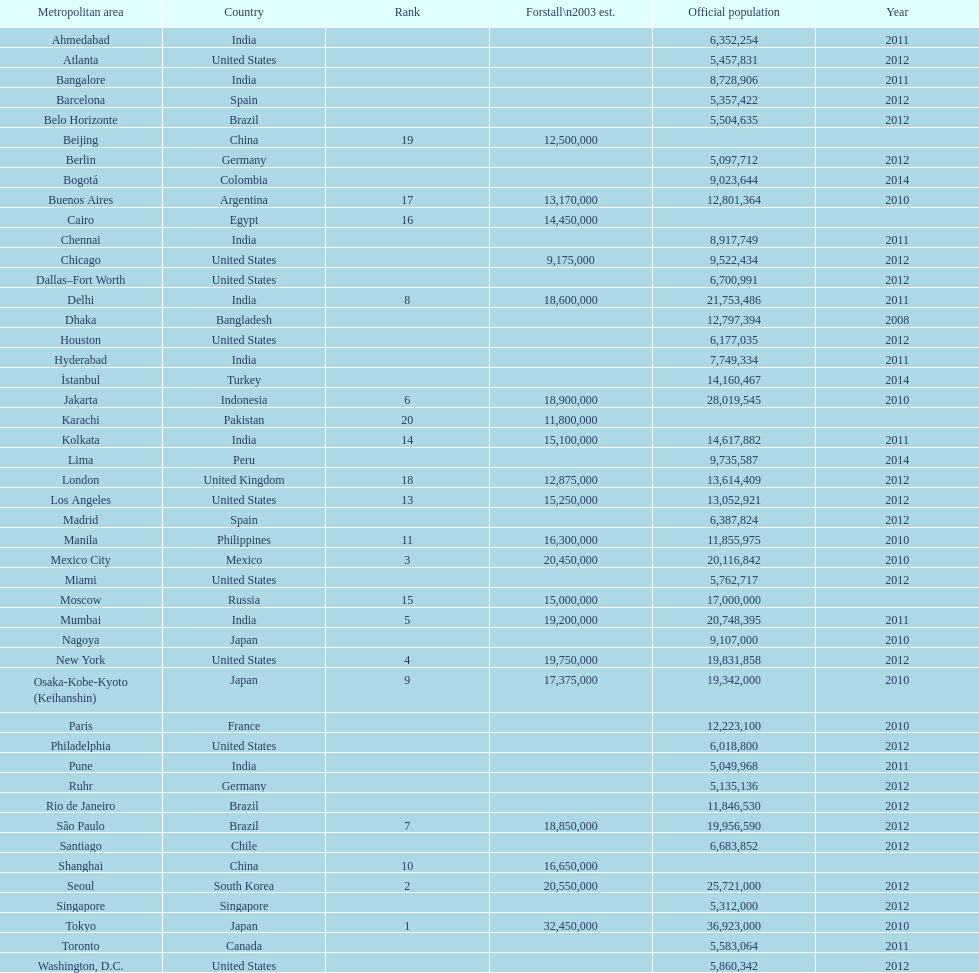Which area is listed above chicago? Chennai. 